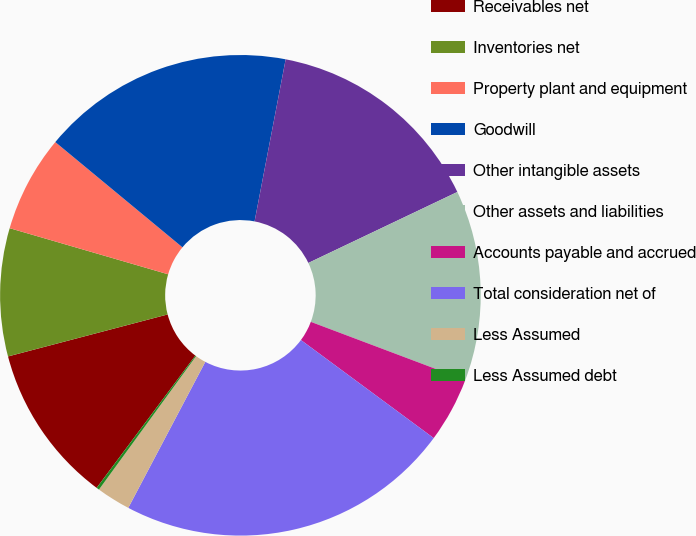<chart> <loc_0><loc_0><loc_500><loc_500><pie_chart><fcel>Receivables net<fcel>Inventories net<fcel>Property plant and equipment<fcel>Goodwill<fcel>Other intangible assets<fcel>Other assets and liabilities<fcel>Accounts payable and accrued<fcel>Total consideration net of<fcel>Less Assumed<fcel>Less Assumed debt<nl><fcel>10.7%<fcel>8.6%<fcel>6.5%<fcel>17.01%<fcel>14.91%<fcel>12.81%<fcel>4.39%<fcel>22.6%<fcel>2.29%<fcel>0.19%<nl></chart> 